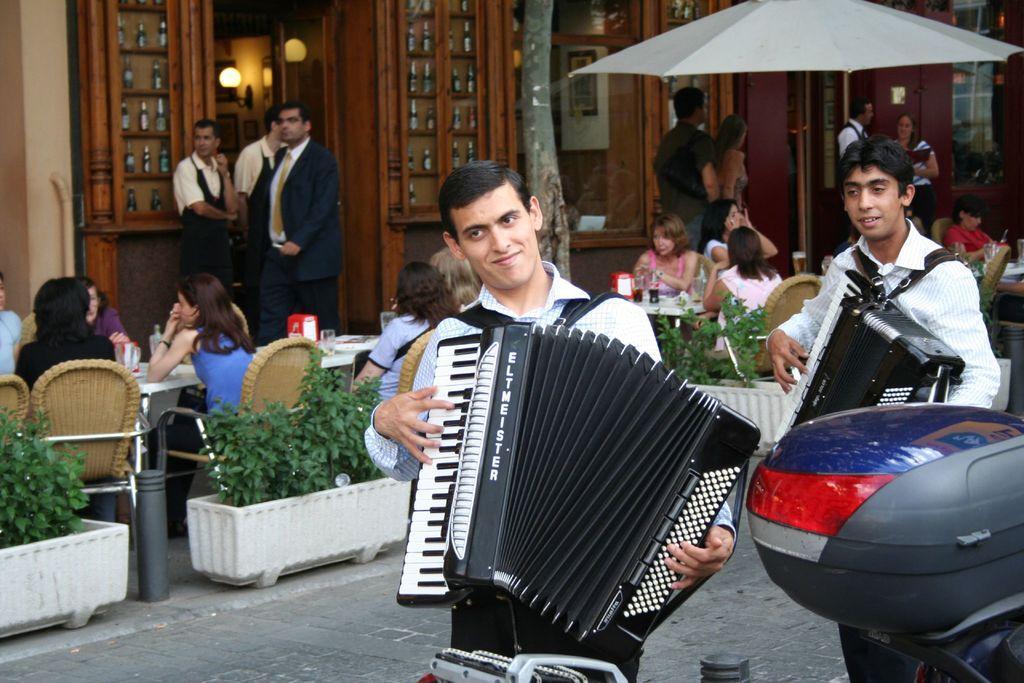How would you summarize this image in a sentence or two? In this picture I can observe two men playing musical instruments in their hands. Behind them I can observe plants in the plant pots. I can observe some people sitting on the chairs in front their respective tables. In the top right side I can observe an umbrella. There are men and women in this picture. 